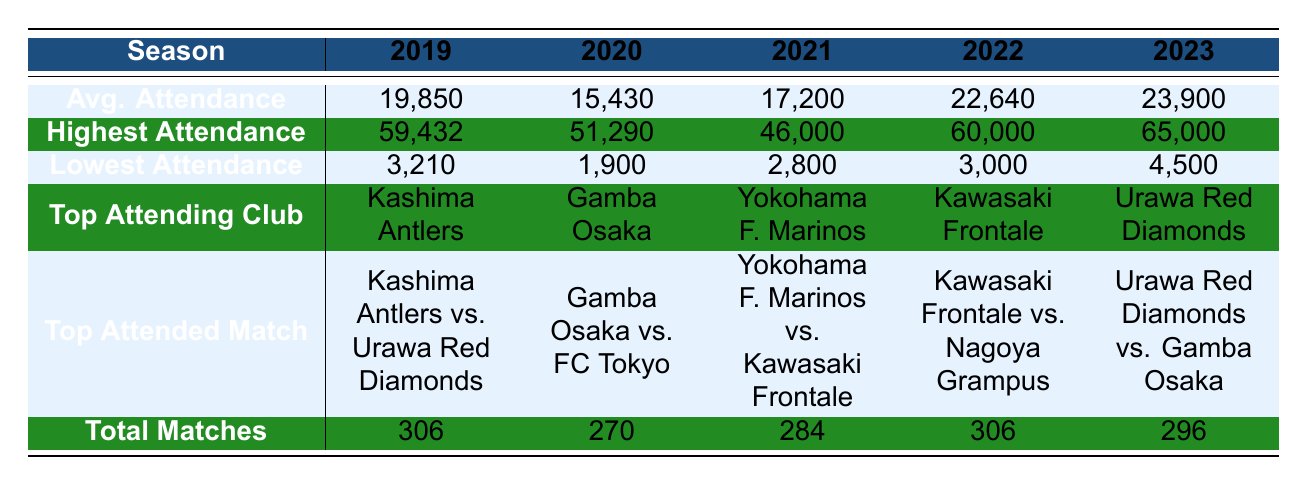What was the average attendance in 2022? The table shows that the average attendance for the season 2022 is listed under the "Avg. Attendance" row for that year, which is 22,640.
Answer: 22,640 Which year had the highest attendance and what was the value? By examining the "Highest Attendance" row, the year 2023 has the highest attendance recorded at 65,000.
Answer: 2023, 65,000 How many total matches were played in 2021? The total matches for the year 2021 can be found in the "Total Matches" row, which states 284 matches were played.
Answer: 284 Did any season have an average attendance below 20,000? Observing the "Avg. Attendance" row, the seasons 2019 (19,850) and 2020 (15,430) both have average attendance figures below 20,000, so the answer is yes.
Answer: Yes What is the difference in total matches played between 2020 and 2022? To find the difference in total matches, subtract the total matches of 2020 (270) from that of 2022 (306). The calculation is 306 - 270 = 36.
Answer: 36 For which match was the highest attendance recorded in 2022? The table indicates that the top attended match in 2022 was "Kawasaki Frontale vs. Nagoya Grampus," which aligns with the highest attendance statistics for that year.
Answer: Kawasaki Frontale vs. Nagoya Grampus Which club had the lowest attendance in 2020 and what was the value? In 2020, the lowest attendance is specified in the "Lowest Attendance" row for that year, which shows the figure of 1,900.
Answer: Gamba Osaka, 1,900 What was the trend in average attendance from 2019 to 2023? By observing the "Avg. Attendance" row data, the average attendance increased from 19,850 in 2019 to 23,900 in 2023. Thus, there is a clear upward trend.
Answer: Increasing trend In which year did the top attending club receive over 20,000 average attendance? Checking the "Avg. Attendance" and "Top Attending Club" rows, we find that both 2022 (22,640) and 2023 (23,900) had average attendances over 20,000, with their respective top clubs being Kawasaki Frontale and Urawa Red Diamonds.
Answer: 2022, 2023 